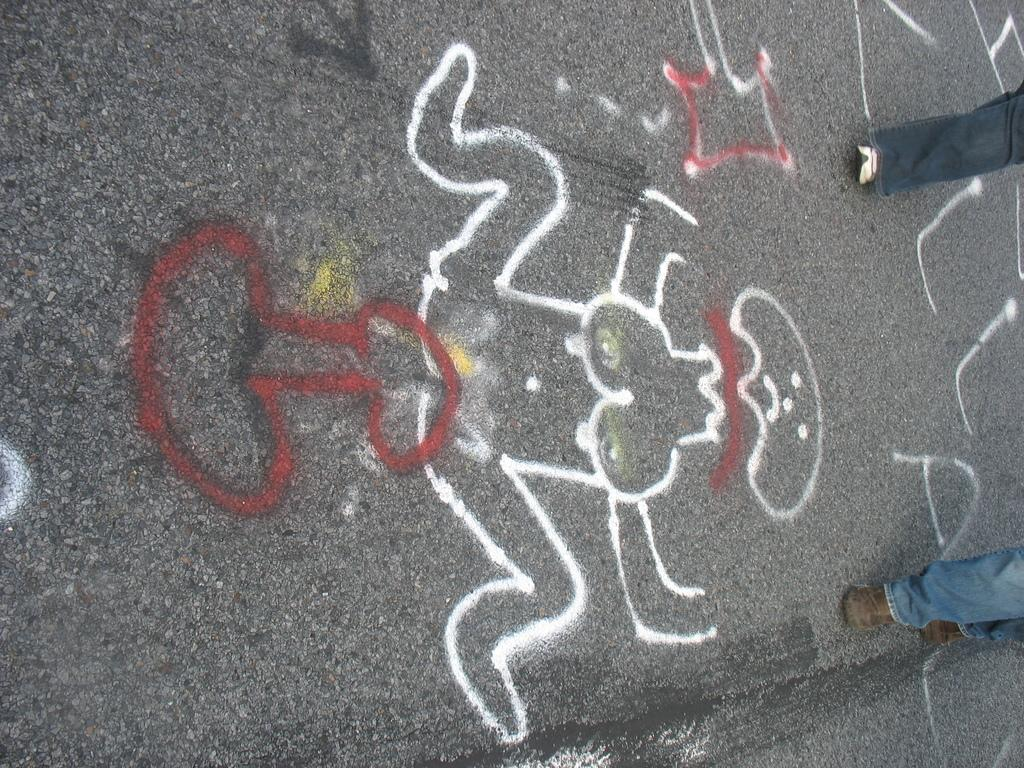What is the main feature of the image? There is a road in the image. Are there any additional details on the road? Yes, there is some painting on the road. Can you describe the people in the image? There are two persons walking on the right side of the road. What type of science experiment is being conducted by the queen in the image? There is no queen or science experiment present in the image. 